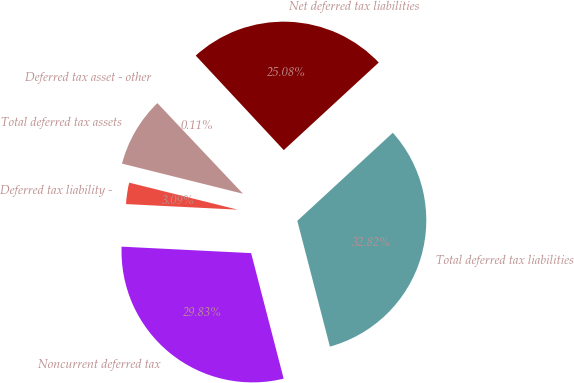<chart> <loc_0><loc_0><loc_500><loc_500><pie_chart><fcel>Deferred tax asset - other<fcel>Total deferred tax assets<fcel>Deferred tax liability -<fcel>Noncurrent deferred tax<fcel>Total deferred tax liabilities<fcel>Net deferred tax liabilities<nl><fcel>0.11%<fcel>9.07%<fcel>3.09%<fcel>29.83%<fcel>32.82%<fcel>25.08%<nl></chart> 